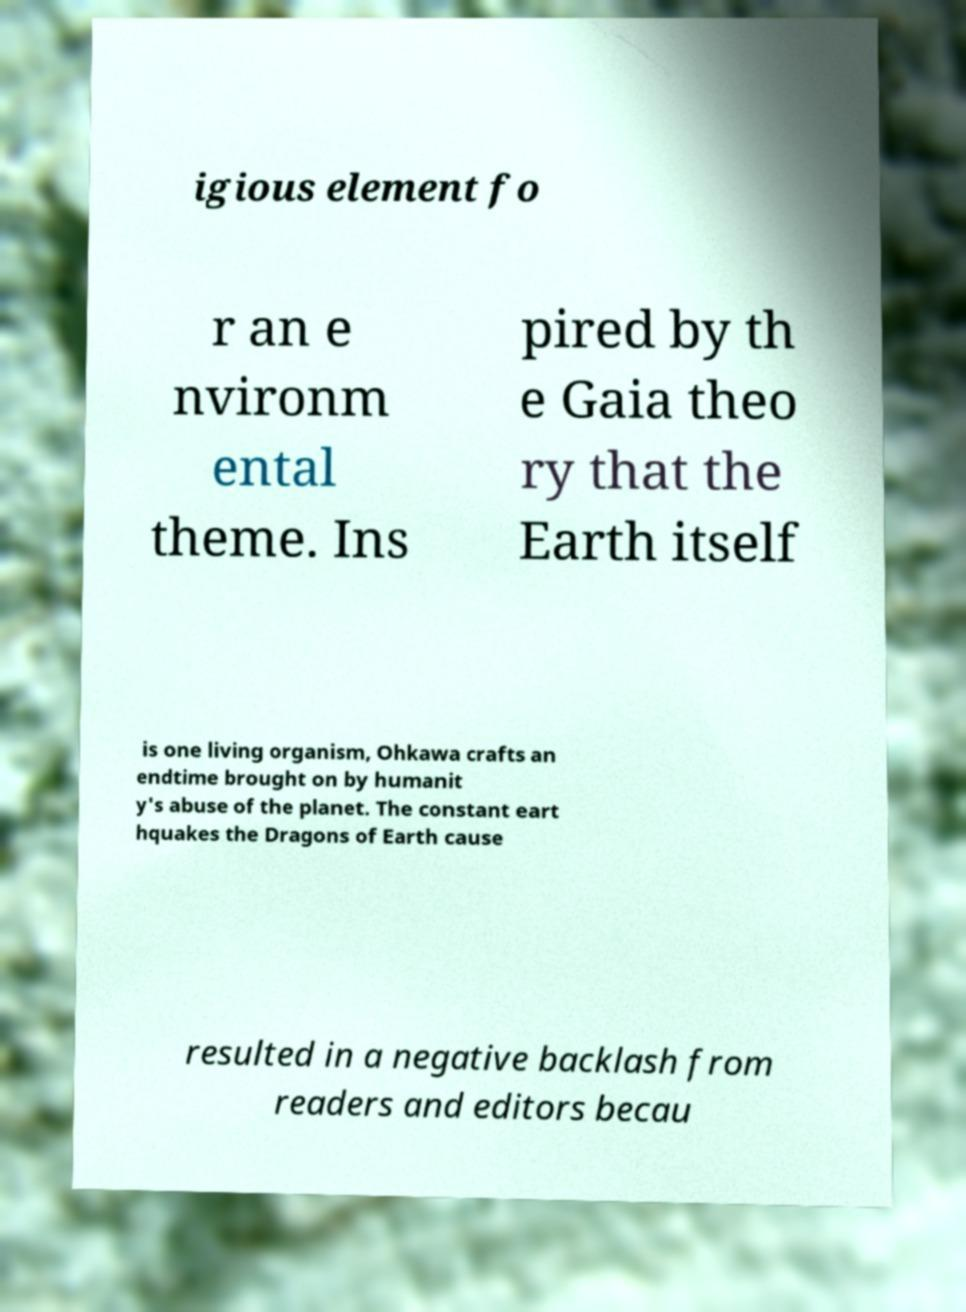I need the written content from this picture converted into text. Can you do that? igious element fo r an e nvironm ental theme. Ins pired by th e Gaia theo ry that the Earth itself is one living organism, Ohkawa crafts an endtime brought on by humanit y's abuse of the planet. The constant eart hquakes the Dragons of Earth cause resulted in a negative backlash from readers and editors becau 